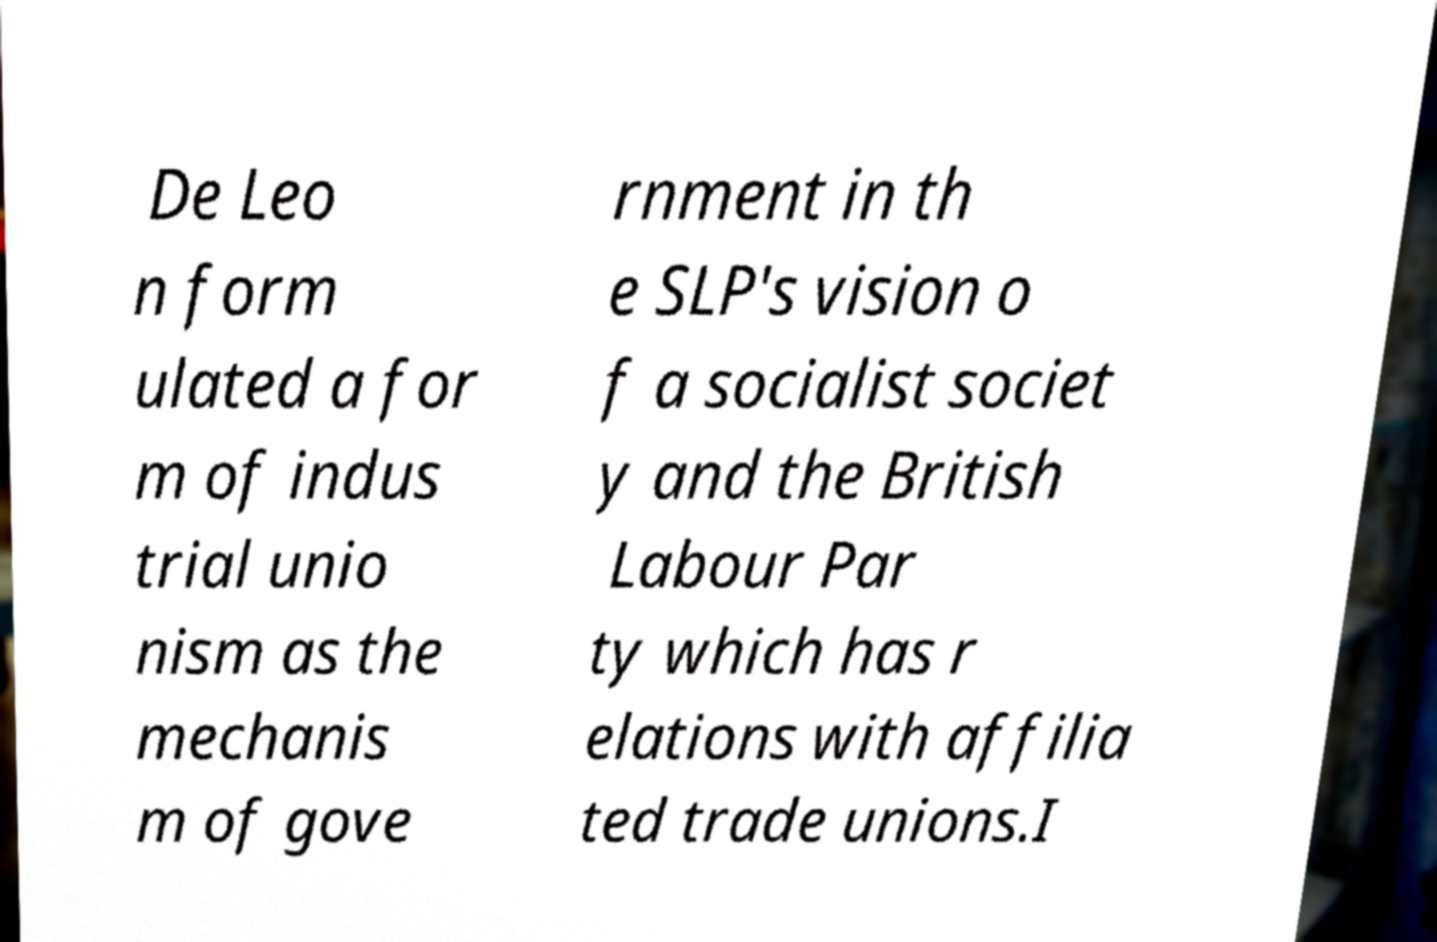I need the written content from this picture converted into text. Can you do that? De Leo n form ulated a for m of indus trial unio nism as the mechanis m of gove rnment in th e SLP's vision o f a socialist societ y and the British Labour Par ty which has r elations with affilia ted trade unions.I 